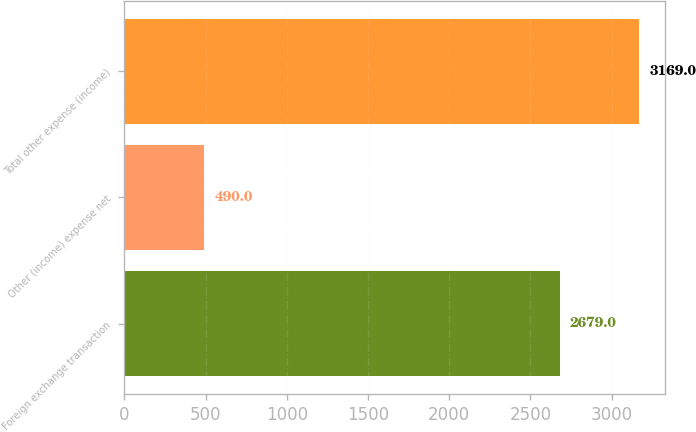Convert chart. <chart><loc_0><loc_0><loc_500><loc_500><bar_chart><fcel>Foreign exchange transaction<fcel>Other (income) expense net<fcel>Total other expense (income)<nl><fcel>2679<fcel>490<fcel>3169<nl></chart> 